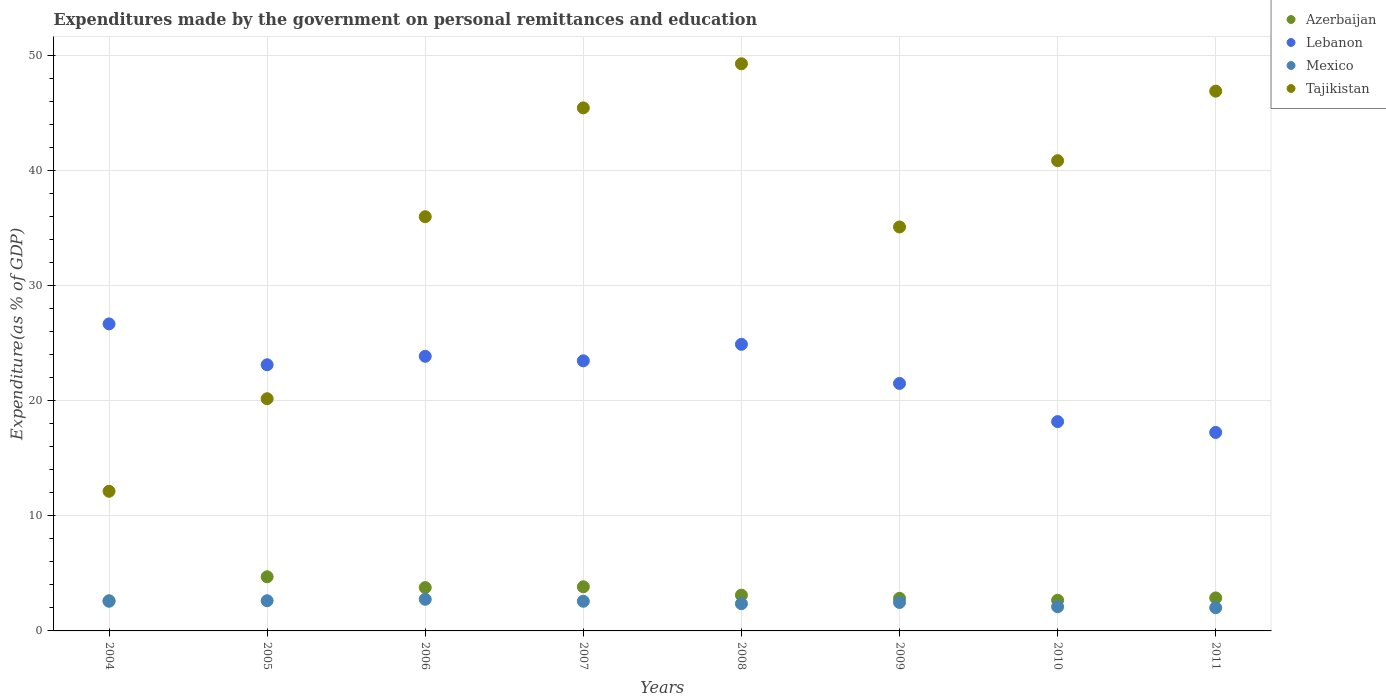How many different coloured dotlines are there?
Make the answer very short. 4. What is the expenditures made by the government on personal remittances and education in Lebanon in 2011?
Give a very brief answer. 17.25. Across all years, what is the maximum expenditures made by the government on personal remittances and education in Lebanon?
Your answer should be very brief. 26.68. Across all years, what is the minimum expenditures made by the government on personal remittances and education in Mexico?
Offer a terse response. 2.02. What is the total expenditures made by the government on personal remittances and education in Lebanon in the graph?
Keep it short and to the point. 179.01. What is the difference between the expenditures made by the government on personal remittances and education in Tajikistan in 2005 and that in 2009?
Make the answer very short. -14.93. What is the difference between the expenditures made by the government on personal remittances and education in Tajikistan in 2007 and the expenditures made by the government on personal remittances and education in Azerbaijan in 2008?
Provide a short and direct response. 42.35. What is the average expenditures made by the government on personal remittances and education in Lebanon per year?
Make the answer very short. 22.38. In the year 2005, what is the difference between the expenditures made by the government on personal remittances and education in Tajikistan and expenditures made by the government on personal remittances and education in Lebanon?
Your answer should be very brief. -2.95. What is the ratio of the expenditures made by the government on personal remittances and education in Azerbaijan in 2008 to that in 2010?
Your response must be concise. 1.17. What is the difference between the highest and the second highest expenditures made by the government on personal remittances and education in Azerbaijan?
Offer a terse response. 0.87. What is the difference between the highest and the lowest expenditures made by the government on personal remittances and education in Tajikistan?
Your answer should be compact. 37.15. In how many years, is the expenditures made by the government on personal remittances and education in Lebanon greater than the average expenditures made by the government on personal remittances and education in Lebanon taken over all years?
Offer a very short reply. 5. Is the sum of the expenditures made by the government on personal remittances and education in Tajikistan in 2008 and 2011 greater than the maximum expenditures made by the government on personal remittances and education in Mexico across all years?
Offer a terse response. Yes. Is it the case that in every year, the sum of the expenditures made by the government on personal remittances and education in Lebanon and expenditures made by the government on personal remittances and education in Azerbaijan  is greater than the sum of expenditures made by the government on personal remittances and education in Tajikistan and expenditures made by the government on personal remittances and education in Mexico?
Give a very brief answer. No. Does the expenditures made by the government on personal remittances and education in Lebanon monotonically increase over the years?
Ensure brevity in your answer.  No. How many years are there in the graph?
Keep it short and to the point. 8. Does the graph contain any zero values?
Offer a terse response. No. How are the legend labels stacked?
Give a very brief answer. Vertical. What is the title of the graph?
Your answer should be compact. Expenditures made by the government on personal remittances and education. Does "Liberia" appear as one of the legend labels in the graph?
Your answer should be very brief. No. What is the label or title of the X-axis?
Provide a short and direct response. Years. What is the label or title of the Y-axis?
Your response must be concise. Expenditure(as % of GDP). What is the Expenditure(as % of GDP) in Azerbaijan in 2004?
Offer a very short reply. 2.62. What is the Expenditure(as % of GDP) of Lebanon in 2004?
Provide a succinct answer. 26.68. What is the Expenditure(as % of GDP) of Mexico in 2004?
Offer a terse response. 2.58. What is the Expenditure(as % of GDP) of Tajikistan in 2004?
Your answer should be very brief. 12.14. What is the Expenditure(as % of GDP) of Azerbaijan in 2005?
Give a very brief answer. 4.71. What is the Expenditure(as % of GDP) in Lebanon in 2005?
Give a very brief answer. 23.13. What is the Expenditure(as % of GDP) of Mexico in 2005?
Ensure brevity in your answer.  2.63. What is the Expenditure(as % of GDP) in Tajikistan in 2005?
Make the answer very short. 20.18. What is the Expenditure(as % of GDP) in Azerbaijan in 2006?
Offer a very short reply. 3.77. What is the Expenditure(as % of GDP) of Lebanon in 2006?
Provide a succinct answer. 23.87. What is the Expenditure(as % of GDP) of Mexico in 2006?
Your answer should be compact. 2.75. What is the Expenditure(as % of GDP) in Tajikistan in 2006?
Offer a terse response. 36. What is the Expenditure(as % of GDP) of Azerbaijan in 2007?
Your answer should be very brief. 3.84. What is the Expenditure(as % of GDP) in Lebanon in 2007?
Ensure brevity in your answer.  23.47. What is the Expenditure(as % of GDP) of Mexico in 2007?
Make the answer very short. 2.58. What is the Expenditure(as % of GDP) of Tajikistan in 2007?
Offer a very short reply. 45.46. What is the Expenditure(as % of GDP) in Azerbaijan in 2008?
Provide a succinct answer. 3.11. What is the Expenditure(as % of GDP) of Lebanon in 2008?
Your answer should be very brief. 24.91. What is the Expenditure(as % of GDP) of Mexico in 2008?
Offer a terse response. 2.36. What is the Expenditure(as % of GDP) of Tajikistan in 2008?
Your answer should be very brief. 49.29. What is the Expenditure(as % of GDP) of Azerbaijan in 2009?
Offer a terse response. 2.83. What is the Expenditure(as % of GDP) of Lebanon in 2009?
Your response must be concise. 21.51. What is the Expenditure(as % of GDP) in Mexico in 2009?
Offer a very short reply. 2.47. What is the Expenditure(as % of GDP) in Tajikistan in 2009?
Your response must be concise. 35.11. What is the Expenditure(as % of GDP) in Azerbaijan in 2010?
Provide a succinct answer. 2.67. What is the Expenditure(as % of GDP) of Lebanon in 2010?
Offer a terse response. 18.19. What is the Expenditure(as % of GDP) in Mexico in 2010?
Make the answer very short. 2.1. What is the Expenditure(as % of GDP) of Tajikistan in 2010?
Your response must be concise. 40.87. What is the Expenditure(as % of GDP) in Azerbaijan in 2011?
Provide a succinct answer. 2.87. What is the Expenditure(as % of GDP) in Lebanon in 2011?
Ensure brevity in your answer.  17.25. What is the Expenditure(as % of GDP) of Mexico in 2011?
Keep it short and to the point. 2.02. What is the Expenditure(as % of GDP) in Tajikistan in 2011?
Give a very brief answer. 46.91. Across all years, what is the maximum Expenditure(as % of GDP) of Azerbaijan?
Make the answer very short. 4.71. Across all years, what is the maximum Expenditure(as % of GDP) of Lebanon?
Provide a short and direct response. 26.68. Across all years, what is the maximum Expenditure(as % of GDP) in Mexico?
Your answer should be very brief. 2.75. Across all years, what is the maximum Expenditure(as % of GDP) of Tajikistan?
Your response must be concise. 49.29. Across all years, what is the minimum Expenditure(as % of GDP) of Azerbaijan?
Offer a terse response. 2.62. Across all years, what is the minimum Expenditure(as % of GDP) of Lebanon?
Your answer should be compact. 17.25. Across all years, what is the minimum Expenditure(as % of GDP) in Mexico?
Provide a short and direct response. 2.02. Across all years, what is the minimum Expenditure(as % of GDP) in Tajikistan?
Make the answer very short. 12.14. What is the total Expenditure(as % of GDP) in Azerbaijan in the graph?
Ensure brevity in your answer.  26.41. What is the total Expenditure(as % of GDP) of Lebanon in the graph?
Your answer should be very brief. 179.01. What is the total Expenditure(as % of GDP) in Mexico in the graph?
Ensure brevity in your answer.  19.49. What is the total Expenditure(as % of GDP) of Tajikistan in the graph?
Ensure brevity in your answer.  285.95. What is the difference between the Expenditure(as % of GDP) in Azerbaijan in 2004 and that in 2005?
Give a very brief answer. -2.08. What is the difference between the Expenditure(as % of GDP) of Lebanon in 2004 and that in 2005?
Offer a very short reply. 3.55. What is the difference between the Expenditure(as % of GDP) in Mexico in 2004 and that in 2005?
Offer a very short reply. -0.05. What is the difference between the Expenditure(as % of GDP) of Tajikistan in 2004 and that in 2005?
Keep it short and to the point. -8.04. What is the difference between the Expenditure(as % of GDP) of Azerbaijan in 2004 and that in 2006?
Provide a succinct answer. -1.14. What is the difference between the Expenditure(as % of GDP) of Lebanon in 2004 and that in 2006?
Keep it short and to the point. 2.82. What is the difference between the Expenditure(as % of GDP) of Mexico in 2004 and that in 2006?
Provide a short and direct response. -0.17. What is the difference between the Expenditure(as % of GDP) of Tajikistan in 2004 and that in 2006?
Give a very brief answer. -23.86. What is the difference between the Expenditure(as % of GDP) in Azerbaijan in 2004 and that in 2007?
Make the answer very short. -1.21. What is the difference between the Expenditure(as % of GDP) in Lebanon in 2004 and that in 2007?
Provide a succinct answer. 3.21. What is the difference between the Expenditure(as % of GDP) in Mexico in 2004 and that in 2007?
Keep it short and to the point. 0. What is the difference between the Expenditure(as % of GDP) of Tajikistan in 2004 and that in 2007?
Offer a terse response. -33.32. What is the difference between the Expenditure(as % of GDP) of Azerbaijan in 2004 and that in 2008?
Your answer should be very brief. -0.49. What is the difference between the Expenditure(as % of GDP) in Lebanon in 2004 and that in 2008?
Offer a very short reply. 1.78. What is the difference between the Expenditure(as % of GDP) in Mexico in 2004 and that in 2008?
Your answer should be compact. 0.21. What is the difference between the Expenditure(as % of GDP) of Tajikistan in 2004 and that in 2008?
Ensure brevity in your answer.  -37.15. What is the difference between the Expenditure(as % of GDP) in Azerbaijan in 2004 and that in 2009?
Give a very brief answer. -0.21. What is the difference between the Expenditure(as % of GDP) of Lebanon in 2004 and that in 2009?
Make the answer very short. 5.17. What is the difference between the Expenditure(as % of GDP) of Mexico in 2004 and that in 2009?
Make the answer very short. 0.11. What is the difference between the Expenditure(as % of GDP) in Tajikistan in 2004 and that in 2009?
Offer a terse response. -22.97. What is the difference between the Expenditure(as % of GDP) in Azerbaijan in 2004 and that in 2010?
Keep it short and to the point. -0.04. What is the difference between the Expenditure(as % of GDP) in Lebanon in 2004 and that in 2010?
Provide a succinct answer. 8.49. What is the difference between the Expenditure(as % of GDP) in Mexico in 2004 and that in 2010?
Give a very brief answer. 0.48. What is the difference between the Expenditure(as % of GDP) in Tajikistan in 2004 and that in 2010?
Offer a terse response. -28.73. What is the difference between the Expenditure(as % of GDP) of Azerbaijan in 2004 and that in 2011?
Keep it short and to the point. -0.25. What is the difference between the Expenditure(as % of GDP) of Lebanon in 2004 and that in 2011?
Offer a terse response. 9.43. What is the difference between the Expenditure(as % of GDP) in Mexico in 2004 and that in 2011?
Provide a succinct answer. 0.56. What is the difference between the Expenditure(as % of GDP) of Tajikistan in 2004 and that in 2011?
Keep it short and to the point. -34.77. What is the difference between the Expenditure(as % of GDP) of Azerbaijan in 2005 and that in 2006?
Provide a succinct answer. 0.94. What is the difference between the Expenditure(as % of GDP) in Lebanon in 2005 and that in 2006?
Give a very brief answer. -0.74. What is the difference between the Expenditure(as % of GDP) of Mexico in 2005 and that in 2006?
Offer a terse response. -0.12. What is the difference between the Expenditure(as % of GDP) of Tajikistan in 2005 and that in 2006?
Give a very brief answer. -15.82. What is the difference between the Expenditure(as % of GDP) of Azerbaijan in 2005 and that in 2007?
Your answer should be very brief. 0.87. What is the difference between the Expenditure(as % of GDP) of Lebanon in 2005 and that in 2007?
Offer a very short reply. -0.34. What is the difference between the Expenditure(as % of GDP) of Mexico in 2005 and that in 2007?
Your answer should be compact. 0.05. What is the difference between the Expenditure(as % of GDP) of Tajikistan in 2005 and that in 2007?
Keep it short and to the point. -25.28. What is the difference between the Expenditure(as % of GDP) of Azerbaijan in 2005 and that in 2008?
Ensure brevity in your answer.  1.6. What is the difference between the Expenditure(as % of GDP) of Lebanon in 2005 and that in 2008?
Provide a short and direct response. -1.77. What is the difference between the Expenditure(as % of GDP) of Mexico in 2005 and that in 2008?
Provide a succinct answer. 0.26. What is the difference between the Expenditure(as % of GDP) in Tajikistan in 2005 and that in 2008?
Your response must be concise. -29.11. What is the difference between the Expenditure(as % of GDP) of Azerbaijan in 2005 and that in 2009?
Provide a succinct answer. 1.87. What is the difference between the Expenditure(as % of GDP) in Lebanon in 2005 and that in 2009?
Offer a very short reply. 1.62. What is the difference between the Expenditure(as % of GDP) in Mexico in 2005 and that in 2009?
Provide a succinct answer. 0.15. What is the difference between the Expenditure(as % of GDP) of Tajikistan in 2005 and that in 2009?
Give a very brief answer. -14.93. What is the difference between the Expenditure(as % of GDP) of Azerbaijan in 2005 and that in 2010?
Your answer should be very brief. 2.04. What is the difference between the Expenditure(as % of GDP) of Lebanon in 2005 and that in 2010?
Offer a terse response. 4.94. What is the difference between the Expenditure(as % of GDP) of Mexico in 2005 and that in 2010?
Your answer should be very brief. 0.52. What is the difference between the Expenditure(as % of GDP) in Tajikistan in 2005 and that in 2010?
Provide a succinct answer. -20.69. What is the difference between the Expenditure(as % of GDP) of Azerbaijan in 2005 and that in 2011?
Your answer should be compact. 1.83. What is the difference between the Expenditure(as % of GDP) in Lebanon in 2005 and that in 2011?
Your answer should be compact. 5.88. What is the difference between the Expenditure(as % of GDP) in Mexico in 2005 and that in 2011?
Provide a short and direct response. 0.61. What is the difference between the Expenditure(as % of GDP) in Tajikistan in 2005 and that in 2011?
Your answer should be compact. -26.73. What is the difference between the Expenditure(as % of GDP) of Azerbaijan in 2006 and that in 2007?
Give a very brief answer. -0.07. What is the difference between the Expenditure(as % of GDP) of Lebanon in 2006 and that in 2007?
Give a very brief answer. 0.39. What is the difference between the Expenditure(as % of GDP) of Mexico in 2006 and that in 2007?
Provide a short and direct response. 0.17. What is the difference between the Expenditure(as % of GDP) of Tajikistan in 2006 and that in 2007?
Make the answer very short. -9.46. What is the difference between the Expenditure(as % of GDP) in Azerbaijan in 2006 and that in 2008?
Give a very brief answer. 0.66. What is the difference between the Expenditure(as % of GDP) of Lebanon in 2006 and that in 2008?
Provide a succinct answer. -1.04. What is the difference between the Expenditure(as % of GDP) of Mexico in 2006 and that in 2008?
Give a very brief answer. 0.39. What is the difference between the Expenditure(as % of GDP) of Tajikistan in 2006 and that in 2008?
Keep it short and to the point. -13.29. What is the difference between the Expenditure(as % of GDP) of Azerbaijan in 2006 and that in 2009?
Provide a short and direct response. 0.93. What is the difference between the Expenditure(as % of GDP) of Lebanon in 2006 and that in 2009?
Ensure brevity in your answer.  2.36. What is the difference between the Expenditure(as % of GDP) of Mexico in 2006 and that in 2009?
Your answer should be very brief. 0.28. What is the difference between the Expenditure(as % of GDP) of Tajikistan in 2006 and that in 2009?
Provide a succinct answer. 0.89. What is the difference between the Expenditure(as % of GDP) of Azerbaijan in 2006 and that in 2010?
Keep it short and to the point. 1.1. What is the difference between the Expenditure(as % of GDP) in Lebanon in 2006 and that in 2010?
Offer a terse response. 5.68. What is the difference between the Expenditure(as % of GDP) in Mexico in 2006 and that in 2010?
Your answer should be compact. 0.65. What is the difference between the Expenditure(as % of GDP) of Tajikistan in 2006 and that in 2010?
Provide a short and direct response. -4.87. What is the difference between the Expenditure(as % of GDP) in Azerbaijan in 2006 and that in 2011?
Give a very brief answer. 0.9. What is the difference between the Expenditure(as % of GDP) of Lebanon in 2006 and that in 2011?
Your response must be concise. 6.62. What is the difference between the Expenditure(as % of GDP) of Mexico in 2006 and that in 2011?
Your answer should be compact. 0.73. What is the difference between the Expenditure(as % of GDP) in Tajikistan in 2006 and that in 2011?
Your response must be concise. -10.91. What is the difference between the Expenditure(as % of GDP) of Azerbaijan in 2007 and that in 2008?
Make the answer very short. 0.73. What is the difference between the Expenditure(as % of GDP) of Lebanon in 2007 and that in 2008?
Offer a terse response. -1.43. What is the difference between the Expenditure(as % of GDP) in Mexico in 2007 and that in 2008?
Keep it short and to the point. 0.21. What is the difference between the Expenditure(as % of GDP) in Tajikistan in 2007 and that in 2008?
Your answer should be compact. -3.83. What is the difference between the Expenditure(as % of GDP) in Azerbaijan in 2007 and that in 2009?
Make the answer very short. 1. What is the difference between the Expenditure(as % of GDP) in Lebanon in 2007 and that in 2009?
Make the answer very short. 1.97. What is the difference between the Expenditure(as % of GDP) in Mexico in 2007 and that in 2009?
Your answer should be very brief. 0.11. What is the difference between the Expenditure(as % of GDP) in Tajikistan in 2007 and that in 2009?
Provide a short and direct response. 10.35. What is the difference between the Expenditure(as % of GDP) in Azerbaijan in 2007 and that in 2010?
Offer a very short reply. 1.17. What is the difference between the Expenditure(as % of GDP) in Lebanon in 2007 and that in 2010?
Ensure brevity in your answer.  5.28. What is the difference between the Expenditure(as % of GDP) in Mexico in 2007 and that in 2010?
Give a very brief answer. 0.47. What is the difference between the Expenditure(as % of GDP) in Tajikistan in 2007 and that in 2010?
Offer a very short reply. 4.59. What is the difference between the Expenditure(as % of GDP) of Azerbaijan in 2007 and that in 2011?
Give a very brief answer. 0.97. What is the difference between the Expenditure(as % of GDP) in Lebanon in 2007 and that in 2011?
Ensure brevity in your answer.  6.22. What is the difference between the Expenditure(as % of GDP) in Mexico in 2007 and that in 2011?
Offer a very short reply. 0.56. What is the difference between the Expenditure(as % of GDP) of Tajikistan in 2007 and that in 2011?
Ensure brevity in your answer.  -1.45. What is the difference between the Expenditure(as % of GDP) in Azerbaijan in 2008 and that in 2009?
Provide a succinct answer. 0.28. What is the difference between the Expenditure(as % of GDP) in Lebanon in 2008 and that in 2009?
Ensure brevity in your answer.  3.4. What is the difference between the Expenditure(as % of GDP) in Mexico in 2008 and that in 2009?
Your response must be concise. -0.11. What is the difference between the Expenditure(as % of GDP) of Tajikistan in 2008 and that in 2009?
Provide a short and direct response. 14.18. What is the difference between the Expenditure(as % of GDP) of Azerbaijan in 2008 and that in 2010?
Your answer should be very brief. 0.44. What is the difference between the Expenditure(as % of GDP) in Lebanon in 2008 and that in 2010?
Keep it short and to the point. 6.72. What is the difference between the Expenditure(as % of GDP) in Mexico in 2008 and that in 2010?
Your answer should be very brief. 0.26. What is the difference between the Expenditure(as % of GDP) in Tajikistan in 2008 and that in 2010?
Your response must be concise. 8.42. What is the difference between the Expenditure(as % of GDP) in Azerbaijan in 2008 and that in 2011?
Your response must be concise. 0.24. What is the difference between the Expenditure(as % of GDP) of Lebanon in 2008 and that in 2011?
Offer a terse response. 7.66. What is the difference between the Expenditure(as % of GDP) in Mexico in 2008 and that in 2011?
Your answer should be compact. 0.35. What is the difference between the Expenditure(as % of GDP) in Tajikistan in 2008 and that in 2011?
Provide a succinct answer. 2.38. What is the difference between the Expenditure(as % of GDP) of Azerbaijan in 2009 and that in 2010?
Provide a succinct answer. 0.17. What is the difference between the Expenditure(as % of GDP) of Lebanon in 2009 and that in 2010?
Give a very brief answer. 3.32. What is the difference between the Expenditure(as % of GDP) in Mexico in 2009 and that in 2010?
Offer a terse response. 0.37. What is the difference between the Expenditure(as % of GDP) in Tajikistan in 2009 and that in 2010?
Keep it short and to the point. -5.76. What is the difference between the Expenditure(as % of GDP) in Azerbaijan in 2009 and that in 2011?
Ensure brevity in your answer.  -0.04. What is the difference between the Expenditure(as % of GDP) of Lebanon in 2009 and that in 2011?
Offer a terse response. 4.26. What is the difference between the Expenditure(as % of GDP) of Mexico in 2009 and that in 2011?
Offer a very short reply. 0.45. What is the difference between the Expenditure(as % of GDP) in Tajikistan in 2009 and that in 2011?
Your answer should be very brief. -11.8. What is the difference between the Expenditure(as % of GDP) in Azerbaijan in 2010 and that in 2011?
Offer a very short reply. -0.2. What is the difference between the Expenditure(as % of GDP) of Lebanon in 2010 and that in 2011?
Ensure brevity in your answer.  0.94. What is the difference between the Expenditure(as % of GDP) of Mexico in 2010 and that in 2011?
Provide a succinct answer. 0.09. What is the difference between the Expenditure(as % of GDP) in Tajikistan in 2010 and that in 2011?
Offer a very short reply. -6.04. What is the difference between the Expenditure(as % of GDP) in Azerbaijan in 2004 and the Expenditure(as % of GDP) in Lebanon in 2005?
Provide a succinct answer. -20.51. What is the difference between the Expenditure(as % of GDP) of Azerbaijan in 2004 and the Expenditure(as % of GDP) of Mexico in 2005?
Your response must be concise. -0. What is the difference between the Expenditure(as % of GDP) in Azerbaijan in 2004 and the Expenditure(as % of GDP) in Tajikistan in 2005?
Give a very brief answer. -17.56. What is the difference between the Expenditure(as % of GDP) of Lebanon in 2004 and the Expenditure(as % of GDP) of Mexico in 2005?
Offer a terse response. 24.06. What is the difference between the Expenditure(as % of GDP) of Lebanon in 2004 and the Expenditure(as % of GDP) of Tajikistan in 2005?
Ensure brevity in your answer.  6.5. What is the difference between the Expenditure(as % of GDP) in Mexico in 2004 and the Expenditure(as % of GDP) in Tajikistan in 2005?
Provide a succinct answer. -17.6. What is the difference between the Expenditure(as % of GDP) in Azerbaijan in 2004 and the Expenditure(as % of GDP) in Lebanon in 2006?
Your response must be concise. -21.25. What is the difference between the Expenditure(as % of GDP) in Azerbaijan in 2004 and the Expenditure(as % of GDP) in Mexico in 2006?
Your response must be concise. -0.13. What is the difference between the Expenditure(as % of GDP) of Azerbaijan in 2004 and the Expenditure(as % of GDP) of Tajikistan in 2006?
Offer a very short reply. -33.38. What is the difference between the Expenditure(as % of GDP) in Lebanon in 2004 and the Expenditure(as % of GDP) in Mexico in 2006?
Give a very brief answer. 23.93. What is the difference between the Expenditure(as % of GDP) of Lebanon in 2004 and the Expenditure(as % of GDP) of Tajikistan in 2006?
Your answer should be compact. -9.32. What is the difference between the Expenditure(as % of GDP) of Mexico in 2004 and the Expenditure(as % of GDP) of Tajikistan in 2006?
Provide a short and direct response. -33.42. What is the difference between the Expenditure(as % of GDP) in Azerbaijan in 2004 and the Expenditure(as % of GDP) in Lebanon in 2007?
Your answer should be compact. -20.85. What is the difference between the Expenditure(as % of GDP) of Azerbaijan in 2004 and the Expenditure(as % of GDP) of Mexico in 2007?
Your response must be concise. 0.04. What is the difference between the Expenditure(as % of GDP) of Azerbaijan in 2004 and the Expenditure(as % of GDP) of Tajikistan in 2007?
Ensure brevity in your answer.  -42.83. What is the difference between the Expenditure(as % of GDP) of Lebanon in 2004 and the Expenditure(as % of GDP) of Mexico in 2007?
Offer a terse response. 24.11. What is the difference between the Expenditure(as % of GDP) in Lebanon in 2004 and the Expenditure(as % of GDP) in Tajikistan in 2007?
Give a very brief answer. -18.77. What is the difference between the Expenditure(as % of GDP) in Mexico in 2004 and the Expenditure(as % of GDP) in Tajikistan in 2007?
Your answer should be compact. -42.88. What is the difference between the Expenditure(as % of GDP) in Azerbaijan in 2004 and the Expenditure(as % of GDP) in Lebanon in 2008?
Keep it short and to the point. -22.29. What is the difference between the Expenditure(as % of GDP) in Azerbaijan in 2004 and the Expenditure(as % of GDP) in Mexico in 2008?
Offer a terse response. 0.26. What is the difference between the Expenditure(as % of GDP) of Azerbaijan in 2004 and the Expenditure(as % of GDP) of Tajikistan in 2008?
Your answer should be compact. -46.67. What is the difference between the Expenditure(as % of GDP) of Lebanon in 2004 and the Expenditure(as % of GDP) of Mexico in 2008?
Offer a terse response. 24.32. What is the difference between the Expenditure(as % of GDP) of Lebanon in 2004 and the Expenditure(as % of GDP) of Tajikistan in 2008?
Your answer should be compact. -22.61. What is the difference between the Expenditure(as % of GDP) in Mexico in 2004 and the Expenditure(as % of GDP) in Tajikistan in 2008?
Offer a very short reply. -46.71. What is the difference between the Expenditure(as % of GDP) in Azerbaijan in 2004 and the Expenditure(as % of GDP) in Lebanon in 2009?
Provide a short and direct response. -18.89. What is the difference between the Expenditure(as % of GDP) in Azerbaijan in 2004 and the Expenditure(as % of GDP) in Mexico in 2009?
Your answer should be very brief. 0.15. What is the difference between the Expenditure(as % of GDP) in Azerbaijan in 2004 and the Expenditure(as % of GDP) in Tajikistan in 2009?
Your answer should be very brief. -32.49. What is the difference between the Expenditure(as % of GDP) of Lebanon in 2004 and the Expenditure(as % of GDP) of Mexico in 2009?
Make the answer very short. 24.21. What is the difference between the Expenditure(as % of GDP) in Lebanon in 2004 and the Expenditure(as % of GDP) in Tajikistan in 2009?
Give a very brief answer. -8.42. What is the difference between the Expenditure(as % of GDP) of Mexico in 2004 and the Expenditure(as % of GDP) of Tajikistan in 2009?
Your response must be concise. -32.53. What is the difference between the Expenditure(as % of GDP) in Azerbaijan in 2004 and the Expenditure(as % of GDP) in Lebanon in 2010?
Offer a terse response. -15.57. What is the difference between the Expenditure(as % of GDP) in Azerbaijan in 2004 and the Expenditure(as % of GDP) in Mexico in 2010?
Offer a very short reply. 0.52. What is the difference between the Expenditure(as % of GDP) of Azerbaijan in 2004 and the Expenditure(as % of GDP) of Tajikistan in 2010?
Offer a terse response. -38.25. What is the difference between the Expenditure(as % of GDP) in Lebanon in 2004 and the Expenditure(as % of GDP) in Mexico in 2010?
Offer a very short reply. 24.58. What is the difference between the Expenditure(as % of GDP) in Lebanon in 2004 and the Expenditure(as % of GDP) in Tajikistan in 2010?
Keep it short and to the point. -14.18. What is the difference between the Expenditure(as % of GDP) in Mexico in 2004 and the Expenditure(as % of GDP) in Tajikistan in 2010?
Your answer should be compact. -38.29. What is the difference between the Expenditure(as % of GDP) in Azerbaijan in 2004 and the Expenditure(as % of GDP) in Lebanon in 2011?
Offer a very short reply. -14.63. What is the difference between the Expenditure(as % of GDP) of Azerbaijan in 2004 and the Expenditure(as % of GDP) of Mexico in 2011?
Keep it short and to the point. 0.6. What is the difference between the Expenditure(as % of GDP) of Azerbaijan in 2004 and the Expenditure(as % of GDP) of Tajikistan in 2011?
Your response must be concise. -44.29. What is the difference between the Expenditure(as % of GDP) of Lebanon in 2004 and the Expenditure(as % of GDP) of Mexico in 2011?
Ensure brevity in your answer.  24.67. What is the difference between the Expenditure(as % of GDP) of Lebanon in 2004 and the Expenditure(as % of GDP) of Tajikistan in 2011?
Give a very brief answer. -20.23. What is the difference between the Expenditure(as % of GDP) in Mexico in 2004 and the Expenditure(as % of GDP) in Tajikistan in 2011?
Make the answer very short. -44.33. What is the difference between the Expenditure(as % of GDP) in Azerbaijan in 2005 and the Expenditure(as % of GDP) in Lebanon in 2006?
Offer a very short reply. -19.16. What is the difference between the Expenditure(as % of GDP) in Azerbaijan in 2005 and the Expenditure(as % of GDP) in Mexico in 2006?
Your answer should be compact. 1.96. What is the difference between the Expenditure(as % of GDP) of Azerbaijan in 2005 and the Expenditure(as % of GDP) of Tajikistan in 2006?
Give a very brief answer. -31.29. What is the difference between the Expenditure(as % of GDP) in Lebanon in 2005 and the Expenditure(as % of GDP) in Mexico in 2006?
Your answer should be very brief. 20.38. What is the difference between the Expenditure(as % of GDP) in Lebanon in 2005 and the Expenditure(as % of GDP) in Tajikistan in 2006?
Provide a succinct answer. -12.87. What is the difference between the Expenditure(as % of GDP) in Mexico in 2005 and the Expenditure(as % of GDP) in Tajikistan in 2006?
Keep it short and to the point. -33.37. What is the difference between the Expenditure(as % of GDP) of Azerbaijan in 2005 and the Expenditure(as % of GDP) of Lebanon in 2007?
Keep it short and to the point. -18.77. What is the difference between the Expenditure(as % of GDP) in Azerbaijan in 2005 and the Expenditure(as % of GDP) in Mexico in 2007?
Give a very brief answer. 2.13. What is the difference between the Expenditure(as % of GDP) of Azerbaijan in 2005 and the Expenditure(as % of GDP) of Tajikistan in 2007?
Offer a terse response. -40.75. What is the difference between the Expenditure(as % of GDP) in Lebanon in 2005 and the Expenditure(as % of GDP) in Mexico in 2007?
Offer a terse response. 20.56. What is the difference between the Expenditure(as % of GDP) in Lebanon in 2005 and the Expenditure(as % of GDP) in Tajikistan in 2007?
Provide a short and direct response. -22.32. What is the difference between the Expenditure(as % of GDP) of Mexico in 2005 and the Expenditure(as % of GDP) of Tajikistan in 2007?
Give a very brief answer. -42.83. What is the difference between the Expenditure(as % of GDP) of Azerbaijan in 2005 and the Expenditure(as % of GDP) of Lebanon in 2008?
Your response must be concise. -20.2. What is the difference between the Expenditure(as % of GDP) of Azerbaijan in 2005 and the Expenditure(as % of GDP) of Mexico in 2008?
Offer a very short reply. 2.34. What is the difference between the Expenditure(as % of GDP) of Azerbaijan in 2005 and the Expenditure(as % of GDP) of Tajikistan in 2008?
Provide a succinct answer. -44.59. What is the difference between the Expenditure(as % of GDP) of Lebanon in 2005 and the Expenditure(as % of GDP) of Mexico in 2008?
Offer a terse response. 20.77. What is the difference between the Expenditure(as % of GDP) of Lebanon in 2005 and the Expenditure(as % of GDP) of Tajikistan in 2008?
Give a very brief answer. -26.16. What is the difference between the Expenditure(as % of GDP) in Mexico in 2005 and the Expenditure(as % of GDP) in Tajikistan in 2008?
Offer a terse response. -46.67. What is the difference between the Expenditure(as % of GDP) of Azerbaijan in 2005 and the Expenditure(as % of GDP) of Lebanon in 2009?
Provide a succinct answer. -16.8. What is the difference between the Expenditure(as % of GDP) in Azerbaijan in 2005 and the Expenditure(as % of GDP) in Mexico in 2009?
Provide a succinct answer. 2.23. What is the difference between the Expenditure(as % of GDP) of Azerbaijan in 2005 and the Expenditure(as % of GDP) of Tajikistan in 2009?
Your answer should be compact. -30.4. What is the difference between the Expenditure(as % of GDP) of Lebanon in 2005 and the Expenditure(as % of GDP) of Mexico in 2009?
Keep it short and to the point. 20.66. What is the difference between the Expenditure(as % of GDP) in Lebanon in 2005 and the Expenditure(as % of GDP) in Tajikistan in 2009?
Your response must be concise. -11.97. What is the difference between the Expenditure(as % of GDP) in Mexico in 2005 and the Expenditure(as % of GDP) in Tajikistan in 2009?
Ensure brevity in your answer.  -32.48. What is the difference between the Expenditure(as % of GDP) in Azerbaijan in 2005 and the Expenditure(as % of GDP) in Lebanon in 2010?
Keep it short and to the point. -13.48. What is the difference between the Expenditure(as % of GDP) of Azerbaijan in 2005 and the Expenditure(as % of GDP) of Mexico in 2010?
Offer a terse response. 2.6. What is the difference between the Expenditure(as % of GDP) of Azerbaijan in 2005 and the Expenditure(as % of GDP) of Tajikistan in 2010?
Provide a short and direct response. -36.16. What is the difference between the Expenditure(as % of GDP) in Lebanon in 2005 and the Expenditure(as % of GDP) in Mexico in 2010?
Provide a short and direct response. 21.03. What is the difference between the Expenditure(as % of GDP) of Lebanon in 2005 and the Expenditure(as % of GDP) of Tajikistan in 2010?
Your answer should be compact. -17.73. What is the difference between the Expenditure(as % of GDP) of Mexico in 2005 and the Expenditure(as % of GDP) of Tajikistan in 2010?
Offer a very short reply. -38.24. What is the difference between the Expenditure(as % of GDP) of Azerbaijan in 2005 and the Expenditure(as % of GDP) of Lebanon in 2011?
Offer a very short reply. -12.54. What is the difference between the Expenditure(as % of GDP) in Azerbaijan in 2005 and the Expenditure(as % of GDP) in Mexico in 2011?
Your answer should be very brief. 2.69. What is the difference between the Expenditure(as % of GDP) of Azerbaijan in 2005 and the Expenditure(as % of GDP) of Tajikistan in 2011?
Offer a very short reply. -42.21. What is the difference between the Expenditure(as % of GDP) of Lebanon in 2005 and the Expenditure(as % of GDP) of Mexico in 2011?
Keep it short and to the point. 21.12. What is the difference between the Expenditure(as % of GDP) in Lebanon in 2005 and the Expenditure(as % of GDP) in Tajikistan in 2011?
Offer a very short reply. -23.78. What is the difference between the Expenditure(as % of GDP) of Mexico in 2005 and the Expenditure(as % of GDP) of Tajikistan in 2011?
Your response must be concise. -44.29. What is the difference between the Expenditure(as % of GDP) in Azerbaijan in 2006 and the Expenditure(as % of GDP) in Lebanon in 2007?
Your response must be concise. -19.71. What is the difference between the Expenditure(as % of GDP) of Azerbaijan in 2006 and the Expenditure(as % of GDP) of Mexico in 2007?
Make the answer very short. 1.19. What is the difference between the Expenditure(as % of GDP) of Azerbaijan in 2006 and the Expenditure(as % of GDP) of Tajikistan in 2007?
Give a very brief answer. -41.69. What is the difference between the Expenditure(as % of GDP) in Lebanon in 2006 and the Expenditure(as % of GDP) in Mexico in 2007?
Offer a terse response. 21.29. What is the difference between the Expenditure(as % of GDP) of Lebanon in 2006 and the Expenditure(as % of GDP) of Tajikistan in 2007?
Your response must be concise. -21.59. What is the difference between the Expenditure(as % of GDP) of Mexico in 2006 and the Expenditure(as % of GDP) of Tajikistan in 2007?
Your answer should be compact. -42.71. What is the difference between the Expenditure(as % of GDP) of Azerbaijan in 2006 and the Expenditure(as % of GDP) of Lebanon in 2008?
Your response must be concise. -21.14. What is the difference between the Expenditure(as % of GDP) in Azerbaijan in 2006 and the Expenditure(as % of GDP) in Mexico in 2008?
Your response must be concise. 1.4. What is the difference between the Expenditure(as % of GDP) of Azerbaijan in 2006 and the Expenditure(as % of GDP) of Tajikistan in 2008?
Your answer should be very brief. -45.52. What is the difference between the Expenditure(as % of GDP) in Lebanon in 2006 and the Expenditure(as % of GDP) in Mexico in 2008?
Make the answer very short. 21.5. What is the difference between the Expenditure(as % of GDP) of Lebanon in 2006 and the Expenditure(as % of GDP) of Tajikistan in 2008?
Provide a succinct answer. -25.42. What is the difference between the Expenditure(as % of GDP) in Mexico in 2006 and the Expenditure(as % of GDP) in Tajikistan in 2008?
Ensure brevity in your answer.  -46.54. What is the difference between the Expenditure(as % of GDP) of Azerbaijan in 2006 and the Expenditure(as % of GDP) of Lebanon in 2009?
Give a very brief answer. -17.74. What is the difference between the Expenditure(as % of GDP) of Azerbaijan in 2006 and the Expenditure(as % of GDP) of Mexico in 2009?
Your response must be concise. 1.29. What is the difference between the Expenditure(as % of GDP) of Azerbaijan in 2006 and the Expenditure(as % of GDP) of Tajikistan in 2009?
Provide a short and direct response. -31.34. What is the difference between the Expenditure(as % of GDP) of Lebanon in 2006 and the Expenditure(as % of GDP) of Mexico in 2009?
Ensure brevity in your answer.  21.4. What is the difference between the Expenditure(as % of GDP) in Lebanon in 2006 and the Expenditure(as % of GDP) in Tajikistan in 2009?
Ensure brevity in your answer.  -11.24. What is the difference between the Expenditure(as % of GDP) of Mexico in 2006 and the Expenditure(as % of GDP) of Tajikistan in 2009?
Your response must be concise. -32.36. What is the difference between the Expenditure(as % of GDP) of Azerbaijan in 2006 and the Expenditure(as % of GDP) of Lebanon in 2010?
Keep it short and to the point. -14.42. What is the difference between the Expenditure(as % of GDP) of Azerbaijan in 2006 and the Expenditure(as % of GDP) of Mexico in 2010?
Offer a very short reply. 1.66. What is the difference between the Expenditure(as % of GDP) of Azerbaijan in 2006 and the Expenditure(as % of GDP) of Tajikistan in 2010?
Keep it short and to the point. -37.1. What is the difference between the Expenditure(as % of GDP) of Lebanon in 2006 and the Expenditure(as % of GDP) of Mexico in 2010?
Provide a short and direct response. 21.76. What is the difference between the Expenditure(as % of GDP) in Lebanon in 2006 and the Expenditure(as % of GDP) in Tajikistan in 2010?
Offer a very short reply. -17. What is the difference between the Expenditure(as % of GDP) in Mexico in 2006 and the Expenditure(as % of GDP) in Tajikistan in 2010?
Your answer should be very brief. -38.12. What is the difference between the Expenditure(as % of GDP) of Azerbaijan in 2006 and the Expenditure(as % of GDP) of Lebanon in 2011?
Provide a succinct answer. -13.48. What is the difference between the Expenditure(as % of GDP) in Azerbaijan in 2006 and the Expenditure(as % of GDP) in Mexico in 2011?
Provide a short and direct response. 1.75. What is the difference between the Expenditure(as % of GDP) in Azerbaijan in 2006 and the Expenditure(as % of GDP) in Tajikistan in 2011?
Give a very brief answer. -43.14. What is the difference between the Expenditure(as % of GDP) of Lebanon in 2006 and the Expenditure(as % of GDP) of Mexico in 2011?
Provide a short and direct response. 21.85. What is the difference between the Expenditure(as % of GDP) of Lebanon in 2006 and the Expenditure(as % of GDP) of Tajikistan in 2011?
Your response must be concise. -23.04. What is the difference between the Expenditure(as % of GDP) of Mexico in 2006 and the Expenditure(as % of GDP) of Tajikistan in 2011?
Provide a succinct answer. -44.16. What is the difference between the Expenditure(as % of GDP) of Azerbaijan in 2007 and the Expenditure(as % of GDP) of Lebanon in 2008?
Give a very brief answer. -21.07. What is the difference between the Expenditure(as % of GDP) in Azerbaijan in 2007 and the Expenditure(as % of GDP) in Mexico in 2008?
Make the answer very short. 1.47. What is the difference between the Expenditure(as % of GDP) of Azerbaijan in 2007 and the Expenditure(as % of GDP) of Tajikistan in 2008?
Your answer should be compact. -45.45. What is the difference between the Expenditure(as % of GDP) of Lebanon in 2007 and the Expenditure(as % of GDP) of Mexico in 2008?
Provide a succinct answer. 21.11. What is the difference between the Expenditure(as % of GDP) in Lebanon in 2007 and the Expenditure(as % of GDP) in Tajikistan in 2008?
Provide a succinct answer. -25.82. What is the difference between the Expenditure(as % of GDP) in Mexico in 2007 and the Expenditure(as % of GDP) in Tajikistan in 2008?
Offer a very short reply. -46.71. What is the difference between the Expenditure(as % of GDP) in Azerbaijan in 2007 and the Expenditure(as % of GDP) in Lebanon in 2009?
Make the answer very short. -17.67. What is the difference between the Expenditure(as % of GDP) in Azerbaijan in 2007 and the Expenditure(as % of GDP) in Mexico in 2009?
Offer a very short reply. 1.36. What is the difference between the Expenditure(as % of GDP) of Azerbaijan in 2007 and the Expenditure(as % of GDP) of Tajikistan in 2009?
Provide a short and direct response. -31.27. What is the difference between the Expenditure(as % of GDP) of Lebanon in 2007 and the Expenditure(as % of GDP) of Mexico in 2009?
Keep it short and to the point. 21. What is the difference between the Expenditure(as % of GDP) in Lebanon in 2007 and the Expenditure(as % of GDP) in Tajikistan in 2009?
Make the answer very short. -11.63. What is the difference between the Expenditure(as % of GDP) in Mexico in 2007 and the Expenditure(as % of GDP) in Tajikistan in 2009?
Your answer should be very brief. -32.53. What is the difference between the Expenditure(as % of GDP) in Azerbaijan in 2007 and the Expenditure(as % of GDP) in Lebanon in 2010?
Provide a short and direct response. -14.35. What is the difference between the Expenditure(as % of GDP) in Azerbaijan in 2007 and the Expenditure(as % of GDP) in Mexico in 2010?
Offer a very short reply. 1.73. What is the difference between the Expenditure(as % of GDP) of Azerbaijan in 2007 and the Expenditure(as % of GDP) of Tajikistan in 2010?
Offer a terse response. -37.03. What is the difference between the Expenditure(as % of GDP) of Lebanon in 2007 and the Expenditure(as % of GDP) of Mexico in 2010?
Provide a succinct answer. 21.37. What is the difference between the Expenditure(as % of GDP) of Lebanon in 2007 and the Expenditure(as % of GDP) of Tajikistan in 2010?
Your answer should be compact. -17.39. What is the difference between the Expenditure(as % of GDP) in Mexico in 2007 and the Expenditure(as % of GDP) in Tajikistan in 2010?
Your answer should be compact. -38.29. What is the difference between the Expenditure(as % of GDP) of Azerbaijan in 2007 and the Expenditure(as % of GDP) of Lebanon in 2011?
Give a very brief answer. -13.41. What is the difference between the Expenditure(as % of GDP) in Azerbaijan in 2007 and the Expenditure(as % of GDP) in Mexico in 2011?
Offer a terse response. 1.82. What is the difference between the Expenditure(as % of GDP) of Azerbaijan in 2007 and the Expenditure(as % of GDP) of Tajikistan in 2011?
Provide a short and direct response. -43.08. What is the difference between the Expenditure(as % of GDP) of Lebanon in 2007 and the Expenditure(as % of GDP) of Mexico in 2011?
Ensure brevity in your answer.  21.46. What is the difference between the Expenditure(as % of GDP) in Lebanon in 2007 and the Expenditure(as % of GDP) in Tajikistan in 2011?
Provide a short and direct response. -23.44. What is the difference between the Expenditure(as % of GDP) of Mexico in 2007 and the Expenditure(as % of GDP) of Tajikistan in 2011?
Your answer should be compact. -44.33. What is the difference between the Expenditure(as % of GDP) in Azerbaijan in 2008 and the Expenditure(as % of GDP) in Lebanon in 2009?
Your answer should be compact. -18.4. What is the difference between the Expenditure(as % of GDP) of Azerbaijan in 2008 and the Expenditure(as % of GDP) of Mexico in 2009?
Your answer should be compact. 0.64. What is the difference between the Expenditure(as % of GDP) of Azerbaijan in 2008 and the Expenditure(as % of GDP) of Tajikistan in 2009?
Provide a short and direct response. -32. What is the difference between the Expenditure(as % of GDP) of Lebanon in 2008 and the Expenditure(as % of GDP) of Mexico in 2009?
Provide a succinct answer. 22.44. What is the difference between the Expenditure(as % of GDP) of Lebanon in 2008 and the Expenditure(as % of GDP) of Tajikistan in 2009?
Keep it short and to the point. -10.2. What is the difference between the Expenditure(as % of GDP) of Mexico in 2008 and the Expenditure(as % of GDP) of Tajikistan in 2009?
Provide a succinct answer. -32.74. What is the difference between the Expenditure(as % of GDP) of Azerbaijan in 2008 and the Expenditure(as % of GDP) of Lebanon in 2010?
Your answer should be compact. -15.08. What is the difference between the Expenditure(as % of GDP) in Azerbaijan in 2008 and the Expenditure(as % of GDP) in Mexico in 2010?
Ensure brevity in your answer.  1. What is the difference between the Expenditure(as % of GDP) in Azerbaijan in 2008 and the Expenditure(as % of GDP) in Tajikistan in 2010?
Keep it short and to the point. -37.76. What is the difference between the Expenditure(as % of GDP) of Lebanon in 2008 and the Expenditure(as % of GDP) of Mexico in 2010?
Offer a very short reply. 22.8. What is the difference between the Expenditure(as % of GDP) of Lebanon in 2008 and the Expenditure(as % of GDP) of Tajikistan in 2010?
Ensure brevity in your answer.  -15.96. What is the difference between the Expenditure(as % of GDP) in Mexico in 2008 and the Expenditure(as % of GDP) in Tajikistan in 2010?
Ensure brevity in your answer.  -38.5. What is the difference between the Expenditure(as % of GDP) in Azerbaijan in 2008 and the Expenditure(as % of GDP) in Lebanon in 2011?
Provide a succinct answer. -14.14. What is the difference between the Expenditure(as % of GDP) in Azerbaijan in 2008 and the Expenditure(as % of GDP) in Mexico in 2011?
Provide a succinct answer. 1.09. What is the difference between the Expenditure(as % of GDP) of Azerbaijan in 2008 and the Expenditure(as % of GDP) of Tajikistan in 2011?
Provide a succinct answer. -43.8. What is the difference between the Expenditure(as % of GDP) of Lebanon in 2008 and the Expenditure(as % of GDP) of Mexico in 2011?
Provide a short and direct response. 22.89. What is the difference between the Expenditure(as % of GDP) in Lebanon in 2008 and the Expenditure(as % of GDP) in Tajikistan in 2011?
Offer a very short reply. -22. What is the difference between the Expenditure(as % of GDP) of Mexico in 2008 and the Expenditure(as % of GDP) of Tajikistan in 2011?
Ensure brevity in your answer.  -44.55. What is the difference between the Expenditure(as % of GDP) in Azerbaijan in 2009 and the Expenditure(as % of GDP) in Lebanon in 2010?
Offer a very short reply. -15.36. What is the difference between the Expenditure(as % of GDP) in Azerbaijan in 2009 and the Expenditure(as % of GDP) in Mexico in 2010?
Provide a succinct answer. 0.73. What is the difference between the Expenditure(as % of GDP) in Azerbaijan in 2009 and the Expenditure(as % of GDP) in Tajikistan in 2010?
Give a very brief answer. -38.03. What is the difference between the Expenditure(as % of GDP) in Lebanon in 2009 and the Expenditure(as % of GDP) in Mexico in 2010?
Offer a terse response. 19.41. What is the difference between the Expenditure(as % of GDP) of Lebanon in 2009 and the Expenditure(as % of GDP) of Tajikistan in 2010?
Offer a terse response. -19.36. What is the difference between the Expenditure(as % of GDP) of Mexico in 2009 and the Expenditure(as % of GDP) of Tajikistan in 2010?
Offer a terse response. -38.4. What is the difference between the Expenditure(as % of GDP) of Azerbaijan in 2009 and the Expenditure(as % of GDP) of Lebanon in 2011?
Your answer should be very brief. -14.42. What is the difference between the Expenditure(as % of GDP) of Azerbaijan in 2009 and the Expenditure(as % of GDP) of Mexico in 2011?
Your answer should be compact. 0.82. What is the difference between the Expenditure(as % of GDP) in Azerbaijan in 2009 and the Expenditure(as % of GDP) in Tajikistan in 2011?
Provide a succinct answer. -44.08. What is the difference between the Expenditure(as % of GDP) in Lebanon in 2009 and the Expenditure(as % of GDP) in Mexico in 2011?
Ensure brevity in your answer.  19.49. What is the difference between the Expenditure(as % of GDP) of Lebanon in 2009 and the Expenditure(as % of GDP) of Tajikistan in 2011?
Your answer should be very brief. -25.4. What is the difference between the Expenditure(as % of GDP) in Mexico in 2009 and the Expenditure(as % of GDP) in Tajikistan in 2011?
Give a very brief answer. -44.44. What is the difference between the Expenditure(as % of GDP) in Azerbaijan in 2010 and the Expenditure(as % of GDP) in Lebanon in 2011?
Your response must be concise. -14.58. What is the difference between the Expenditure(as % of GDP) in Azerbaijan in 2010 and the Expenditure(as % of GDP) in Mexico in 2011?
Your answer should be very brief. 0.65. What is the difference between the Expenditure(as % of GDP) of Azerbaijan in 2010 and the Expenditure(as % of GDP) of Tajikistan in 2011?
Your answer should be very brief. -44.24. What is the difference between the Expenditure(as % of GDP) in Lebanon in 2010 and the Expenditure(as % of GDP) in Mexico in 2011?
Make the answer very short. 16.17. What is the difference between the Expenditure(as % of GDP) in Lebanon in 2010 and the Expenditure(as % of GDP) in Tajikistan in 2011?
Ensure brevity in your answer.  -28.72. What is the difference between the Expenditure(as % of GDP) of Mexico in 2010 and the Expenditure(as % of GDP) of Tajikistan in 2011?
Keep it short and to the point. -44.81. What is the average Expenditure(as % of GDP) in Azerbaijan per year?
Your response must be concise. 3.3. What is the average Expenditure(as % of GDP) of Lebanon per year?
Provide a succinct answer. 22.38. What is the average Expenditure(as % of GDP) of Mexico per year?
Make the answer very short. 2.44. What is the average Expenditure(as % of GDP) of Tajikistan per year?
Your answer should be very brief. 35.74. In the year 2004, what is the difference between the Expenditure(as % of GDP) in Azerbaijan and Expenditure(as % of GDP) in Lebanon?
Your answer should be compact. -24.06. In the year 2004, what is the difference between the Expenditure(as % of GDP) in Azerbaijan and Expenditure(as % of GDP) in Mexico?
Your answer should be compact. 0.04. In the year 2004, what is the difference between the Expenditure(as % of GDP) of Azerbaijan and Expenditure(as % of GDP) of Tajikistan?
Your answer should be very brief. -9.52. In the year 2004, what is the difference between the Expenditure(as % of GDP) of Lebanon and Expenditure(as % of GDP) of Mexico?
Your response must be concise. 24.1. In the year 2004, what is the difference between the Expenditure(as % of GDP) of Lebanon and Expenditure(as % of GDP) of Tajikistan?
Provide a short and direct response. 14.54. In the year 2004, what is the difference between the Expenditure(as % of GDP) of Mexico and Expenditure(as % of GDP) of Tajikistan?
Keep it short and to the point. -9.56. In the year 2005, what is the difference between the Expenditure(as % of GDP) in Azerbaijan and Expenditure(as % of GDP) in Lebanon?
Provide a short and direct response. -18.43. In the year 2005, what is the difference between the Expenditure(as % of GDP) of Azerbaijan and Expenditure(as % of GDP) of Mexico?
Keep it short and to the point. 2.08. In the year 2005, what is the difference between the Expenditure(as % of GDP) of Azerbaijan and Expenditure(as % of GDP) of Tajikistan?
Provide a short and direct response. -15.48. In the year 2005, what is the difference between the Expenditure(as % of GDP) in Lebanon and Expenditure(as % of GDP) in Mexico?
Offer a terse response. 20.51. In the year 2005, what is the difference between the Expenditure(as % of GDP) of Lebanon and Expenditure(as % of GDP) of Tajikistan?
Ensure brevity in your answer.  2.95. In the year 2005, what is the difference between the Expenditure(as % of GDP) of Mexico and Expenditure(as % of GDP) of Tajikistan?
Offer a terse response. -17.56. In the year 2006, what is the difference between the Expenditure(as % of GDP) of Azerbaijan and Expenditure(as % of GDP) of Lebanon?
Offer a terse response. -20.1. In the year 2006, what is the difference between the Expenditure(as % of GDP) of Azerbaijan and Expenditure(as % of GDP) of Mexico?
Make the answer very short. 1.02. In the year 2006, what is the difference between the Expenditure(as % of GDP) of Azerbaijan and Expenditure(as % of GDP) of Tajikistan?
Offer a terse response. -32.23. In the year 2006, what is the difference between the Expenditure(as % of GDP) in Lebanon and Expenditure(as % of GDP) in Mexico?
Give a very brief answer. 21.12. In the year 2006, what is the difference between the Expenditure(as % of GDP) of Lebanon and Expenditure(as % of GDP) of Tajikistan?
Offer a terse response. -12.13. In the year 2006, what is the difference between the Expenditure(as % of GDP) in Mexico and Expenditure(as % of GDP) in Tajikistan?
Your answer should be compact. -33.25. In the year 2007, what is the difference between the Expenditure(as % of GDP) of Azerbaijan and Expenditure(as % of GDP) of Lebanon?
Your answer should be compact. -19.64. In the year 2007, what is the difference between the Expenditure(as % of GDP) in Azerbaijan and Expenditure(as % of GDP) in Mexico?
Offer a very short reply. 1.26. In the year 2007, what is the difference between the Expenditure(as % of GDP) in Azerbaijan and Expenditure(as % of GDP) in Tajikistan?
Give a very brief answer. -41.62. In the year 2007, what is the difference between the Expenditure(as % of GDP) of Lebanon and Expenditure(as % of GDP) of Mexico?
Provide a short and direct response. 20.9. In the year 2007, what is the difference between the Expenditure(as % of GDP) in Lebanon and Expenditure(as % of GDP) in Tajikistan?
Your answer should be very brief. -21.98. In the year 2007, what is the difference between the Expenditure(as % of GDP) in Mexico and Expenditure(as % of GDP) in Tajikistan?
Ensure brevity in your answer.  -42.88. In the year 2008, what is the difference between the Expenditure(as % of GDP) of Azerbaijan and Expenditure(as % of GDP) of Lebanon?
Give a very brief answer. -21.8. In the year 2008, what is the difference between the Expenditure(as % of GDP) in Azerbaijan and Expenditure(as % of GDP) in Mexico?
Ensure brevity in your answer.  0.74. In the year 2008, what is the difference between the Expenditure(as % of GDP) of Azerbaijan and Expenditure(as % of GDP) of Tajikistan?
Keep it short and to the point. -46.18. In the year 2008, what is the difference between the Expenditure(as % of GDP) of Lebanon and Expenditure(as % of GDP) of Mexico?
Ensure brevity in your answer.  22.54. In the year 2008, what is the difference between the Expenditure(as % of GDP) of Lebanon and Expenditure(as % of GDP) of Tajikistan?
Give a very brief answer. -24.38. In the year 2008, what is the difference between the Expenditure(as % of GDP) in Mexico and Expenditure(as % of GDP) in Tajikistan?
Offer a very short reply. -46.93. In the year 2009, what is the difference between the Expenditure(as % of GDP) in Azerbaijan and Expenditure(as % of GDP) in Lebanon?
Offer a very short reply. -18.68. In the year 2009, what is the difference between the Expenditure(as % of GDP) in Azerbaijan and Expenditure(as % of GDP) in Mexico?
Keep it short and to the point. 0.36. In the year 2009, what is the difference between the Expenditure(as % of GDP) in Azerbaijan and Expenditure(as % of GDP) in Tajikistan?
Keep it short and to the point. -32.27. In the year 2009, what is the difference between the Expenditure(as % of GDP) in Lebanon and Expenditure(as % of GDP) in Mexico?
Your answer should be very brief. 19.04. In the year 2009, what is the difference between the Expenditure(as % of GDP) of Lebanon and Expenditure(as % of GDP) of Tajikistan?
Keep it short and to the point. -13.6. In the year 2009, what is the difference between the Expenditure(as % of GDP) in Mexico and Expenditure(as % of GDP) in Tajikistan?
Ensure brevity in your answer.  -32.64. In the year 2010, what is the difference between the Expenditure(as % of GDP) in Azerbaijan and Expenditure(as % of GDP) in Lebanon?
Offer a terse response. -15.52. In the year 2010, what is the difference between the Expenditure(as % of GDP) in Azerbaijan and Expenditure(as % of GDP) in Mexico?
Provide a short and direct response. 0.56. In the year 2010, what is the difference between the Expenditure(as % of GDP) in Azerbaijan and Expenditure(as % of GDP) in Tajikistan?
Offer a terse response. -38.2. In the year 2010, what is the difference between the Expenditure(as % of GDP) in Lebanon and Expenditure(as % of GDP) in Mexico?
Your answer should be very brief. 16.09. In the year 2010, what is the difference between the Expenditure(as % of GDP) of Lebanon and Expenditure(as % of GDP) of Tajikistan?
Keep it short and to the point. -22.68. In the year 2010, what is the difference between the Expenditure(as % of GDP) of Mexico and Expenditure(as % of GDP) of Tajikistan?
Keep it short and to the point. -38.76. In the year 2011, what is the difference between the Expenditure(as % of GDP) of Azerbaijan and Expenditure(as % of GDP) of Lebanon?
Ensure brevity in your answer.  -14.38. In the year 2011, what is the difference between the Expenditure(as % of GDP) in Azerbaijan and Expenditure(as % of GDP) in Mexico?
Ensure brevity in your answer.  0.85. In the year 2011, what is the difference between the Expenditure(as % of GDP) in Azerbaijan and Expenditure(as % of GDP) in Tajikistan?
Your response must be concise. -44.04. In the year 2011, what is the difference between the Expenditure(as % of GDP) of Lebanon and Expenditure(as % of GDP) of Mexico?
Make the answer very short. 15.23. In the year 2011, what is the difference between the Expenditure(as % of GDP) in Lebanon and Expenditure(as % of GDP) in Tajikistan?
Give a very brief answer. -29.66. In the year 2011, what is the difference between the Expenditure(as % of GDP) of Mexico and Expenditure(as % of GDP) of Tajikistan?
Keep it short and to the point. -44.89. What is the ratio of the Expenditure(as % of GDP) of Azerbaijan in 2004 to that in 2005?
Offer a very short reply. 0.56. What is the ratio of the Expenditure(as % of GDP) of Lebanon in 2004 to that in 2005?
Keep it short and to the point. 1.15. What is the ratio of the Expenditure(as % of GDP) of Mexico in 2004 to that in 2005?
Offer a terse response. 0.98. What is the ratio of the Expenditure(as % of GDP) in Tajikistan in 2004 to that in 2005?
Keep it short and to the point. 0.6. What is the ratio of the Expenditure(as % of GDP) in Azerbaijan in 2004 to that in 2006?
Keep it short and to the point. 0.7. What is the ratio of the Expenditure(as % of GDP) in Lebanon in 2004 to that in 2006?
Give a very brief answer. 1.12. What is the ratio of the Expenditure(as % of GDP) of Mexico in 2004 to that in 2006?
Give a very brief answer. 0.94. What is the ratio of the Expenditure(as % of GDP) in Tajikistan in 2004 to that in 2006?
Your answer should be compact. 0.34. What is the ratio of the Expenditure(as % of GDP) of Azerbaijan in 2004 to that in 2007?
Offer a very short reply. 0.68. What is the ratio of the Expenditure(as % of GDP) in Lebanon in 2004 to that in 2007?
Provide a succinct answer. 1.14. What is the ratio of the Expenditure(as % of GDP) in Tajikistan in 2004 to that in 2007?
Your answer should be very brief. 0.27. What is the ratio of the Expenditure(as % of GDP) in Azerbaijan in 2004 to that in 2008?
Provide a succinct answer. 0.84. What is the ratio of the Expenditure(as % of GDP) in Lebanon in 2004 to that in 2008?
Make the answer very short. 1.07. What is the ratio of the Expenditure(as % of GDP) of Mexico in 2004 to that in 2008?
Make the answer very short. 1.09. What is the ratio of the Expenditure(as % of GDP) in Tajikistan in 2004 to that in 2008?
Keep it short and to the point. 0.25. What is the ratio of the Expenditure(as % of GDP) of Azerbaijan in 2004 to that in 2009?
Offer a very short reply. 0.93. What is the ratio of the Expenditure(as % of GDP) in Lebanon in 2004 to that in 2009?
Provide a short and direct response. 1.24. What is the ratio of the Expenditure(as % of GDP) in Mexico in 2004 to that in 2009?
Provide a short and direct response. 1.04. What is the ratio of the Expenditure(as % of GDP) of Tajikistan in 2004 to that in 2009?
Provide a short and direct response. 0.35. What is the ratio of the Expenditure(as % of GDP) in Azerbaijan in 2004 to that in 2010?
Your response must be concise. 0.98. What is the ratio of the Expenditure(as % of GDP) of Lebanon in 2004 to that in 2010?
Provide a short and direct response. 1.47. What is the ratio of the Expenditure(as % of GDP) of Mexico in 2004 to that in 2010?
Offer a very short reply. 1.23. What is the ratio of the Expenditure(as % of GDP) in Tajikistan in 2004 to that in 2010?
Provide a succinct answer. 0.3. What is the ratio of the Expenditure(as % of GDP) in Azerbaijan in 2004 to that in 2011?
Your response must be concise. 0.91. What is the ratio of the Expenditure(as % of GDP) in Lebanon in 2004 to that in 2011?
Your answer should be compact. 1.55. What is the ratio of the Expenditure(as % of GDP) of Mexico in 2004 to that in 2011?
Offer a very short reply. 1.28. What is the ratio of the Expenditure(as % of GDP) in Tajikistan in 2004 to that in 2011?
Offer a very short reply. 0.26. What is the ratio of the Expenditure(as % of GDP) of Azerbaijan in 2005 to that in 2006?
Provide a short and direct response. 1.25. What is the ratio of the Expenditure(as % of GDP) of Lebanon in 2005 to that in 2006?
Your answer should be very brief. 0.97. What is the ratio of the Expenditure(as % of GDP) of Mexico in 2005 to that in 2006?
Keep it short and to the point. 0.95. What is the ratio of the Expenditure(as % of GDP) in Tajikistan in 2005 to that in 2006?
Provide a short and direct response. 0.56. What is the ratio of the Expenditure(as % of GDP) in Azerbaijan in 2005 to that in 2007?
Make the answer very short. 1.23. What is the ratio of the Expenditure(as % of GDP) in Lebanon in 2005 to that in 2007?
Offer a very short reply. 0.99. What is the ratio of the Expenditure(as % of GDP) of Mexico in 2005 to that in 2007?
Your response must be concise. 1.02. What is the ratio of the Expenditure(as % of GDP) of Tajikistan in 2005 to that in 2007?
Your answer should be compact. 0.44. What is the ratio of the Expenditure(as % of GDP) of Azerbaijan in 2005 to that in 2008?
Give a very brief answer. 1.51. What is the ratio of the Expenditure(as % of GDP) in Lebanon in 2005 to that in 2008?
Your answer should be compact. 0.93. What is the ratio of the Expenditure(as % of GDP) in Mexico in 2005 to that in 2008?
Make the answer very short. 1.11. What is the ratio of the Expenditure(as % of GDP) of Tajikistan in 2005 to that in 2008?
Offer a terse response. 0.41. What is the ratio of the Expenditure(as % of GDP) in Azerbaijan in 2005 to that in 2009?
Provide a short and direct response. 1.66. What is the ratio of the Expenditure(as % of GDP) in Lebanon in 2005 to that in 2009?
Make the answer very short. 1.08. What is the ratio of the Expenditure(as % of GDP) of Mexico in 2005 to that in 2009?
Keep it short and to the point. 1.06. What is the ratio of the Expenditure(as % of GDP) in Tajikistan in 2005 to that in 2009?
Your answer should be compact. 0.57. What is the ratio of the Expenditure(as % of GDP) in Azerbaijan in 2005 to that in 2010?
Provide a succinct answer. 1.76. What is the ratio of the Expenditure(as % of GDP) in Lebanon in 2005 to that in 2010?
Keep it short and to the point. 1.27. What is the ratio of the Expenditure(as % of GDP) of Mexico in 2005 to that in 2010?
Provide a succinct answer. 1.25. What is the ratio of the Expenditure(as % of GDP) in Tajikistan in 2005 to that in 2010?
Give a very brief answer. 0.49. What is the ratio of the Expenditure(as % of GDP) of Azerbaijan in 2005 to that in 2011?
Provide a succinct answer. 1.64. What is the ratio of the Expenditure(as % of GDP) in Lebanon in 2005 to that in 2011?
Your answer should be very brief. 1.34. What is the ratio of the Expenditure(as % of GDP) in Mexico in 2005 to that in 2011?
Provide a succinct answer. 1.3. What is the ratio of the Expenditure(as % of GDP) in Tajikistan in 2005 to that in 2011?
Provide a succinct answer. 0.43. What is the ratio of the Expenditure(as % of GDP) of Azerbaijan in 2006 to that in 2007?
Offer a terse response. 0.98. What is the ratio of the Expenditure(as % of GDP) of Lebanon in 2006 to that in 2007?
Make the answer very short. 1.02. What is the ratio of the Expenditure(as % of GDP) in Mexico in 2006 to that in 2007?
Your answer should be very brief. 1.07. What is the ratio of the Expenditure(as % of GDP) in Tajikistan in 2006 to that in 2007?
Provide a succinct answer. 0.79. What is the ratio of the Expenditure(as % of GDP) of Azerbaijan in 2006 to that in 2008?
Provide a succinct answer. 1.21. What is the ratio of the Expenditure(as % of GDP) of Mexico in 2006 to that in 2008?
Ensure brevity in your answer.  1.16. What is the ratio of the Expenditure(as % of GDP) in Tajikistan in 2006 to that in 2008?
Your answer should be very brief. 0.73. What is the ratio of the Expenditure(as % of GDP) of Azerbaijan in 2006 to that in 2009?
Ensure brevity in your answer.  1.33. What is the ratio of the Expenditure(as % of GDP) in Lebanon in 2006 to that in 2009?
Offer a terse response. 1.11. What is the ratio of the Expenditure(as % of GDP) of Mexico in 2006 to that in 2009?
Provide a short and direct response. 1.11. What is the ratio of the Expenditure(as % of GDP) of Tajikistan in 2006 to that in 2009?
Your answer should be compact. 1.03. What is the ratio of the Expenditure(as % of GDP) of Azerbaijan in 2006 to that in 2010?
Offer a terse response. 1.41. What is the ratio of the Expenditure(as % of GDP) in Lebanon in 2006 to that in 2010?
Ensure brevity in your answer.  1.31. What is the ratio of the Expenditure(as % of GDP) in Mexico in 2006 to that in 2010?
Make the answer very short. 1.31. What is the ratio of the Expenditure(as % of GDP) of Tajikistan in 2006 to that in 2010?
Offer a very short reply. 0.88. What is the ratio of the Expenditure(as % of GDP) of Azerbaijan in 2006 to that in 2011?
Your response must be concise. 1.31. What is the ratio of the Expenditure(as % of GDP) of Lebanon in 2006 to that in 2011?
Keep it short and to the point. 1.38. What is the ratio of the Expenditure(as % of GDP) in Mexico in 2006 to that in 2011?
Offer a terse response. 1.36. What is the ratio of the Expenditure(as % of GDP) of Tajikistan in 2006 to that in 2011?
Give a very brief answer. 0.77. What is the ratio of the Expenditure(as % of GDP) of Azerbaijan in 2007 to that in 2008?
Your answer should be very brief. 1.23. What is the ratio of the Expenditure(as % of GDP) in Lebanon in 2007 to that in 2008?
Provide a short and direct response. 0.94. What is the ratio of the Expenditure(as % of GDP) in Mexico in 2007 to that in 2008?
Give a very brief answer. 1.09. What is the ratio of the Expenditure(as % of GDP) in Tajikistan in 2007 to that in 2008?
Ensure brevity in your answer.  0.92. What is the ratio of the Expenditure(as % of GDP) of Azerbaijan in 2007 to that in 2009?
Keep it short and to the point. 1.35. What is the ratio of the Expenditure(as % of GDP) in Lebanon in 2007 to that in 2009?
Provide a succinct answer. 1.09. What is the ratio of the Expenditure(as % of GDP) of Mexico in 2007 to that in 2009?
Offer a terse response. 1.04. What is the ratio of the Expenditure(as % of GDP) in Tajikistan in 2007 to that in 2009?
Make the answer very short. 1.29. What is the ratio of the Expenditure(as % of GDP) in Azerbaijan in 2007 to that in 2010?
Make the answer very short. 1.44. What is the ratio of the Expenditure(as % of GDP) in Lebanon in 2007 to that in 2010?
Your response must be concise. 1.29. What is the ratio of the Expenditure(as % of GDP) of Mexico in 2007 to that in 2010?
Give a very brief answer. 1.23. What is the ratio of the Expenditure(as % of GDP) in Tajikistan in 2007 to that in 2010?
Your answer should be very brief. 1.11. What is the ratio of the Expenditure(as % of GDP) of Azerbaijan in 2007 to that in 2011?
Make the answer very short. 1.34. What is the ratio of the Expenditure(as % of GDP) in Lebanon in 2007 to that in 2011?
Your response must be concise. 1.36. What is the ratio of the Expenditure(as % of GDP) of Mexico in 2007 to that in 2011?
Provide a succinct answer. 1.28. What is the ratio of the Expenditure(as % of GDP) of Azerbaijan in 2008 to that in 2009?
Your answer should be very brief. 1.1. What is the ratio of the Expenditure(as % of GDP) of Lebanon in 2008 to that in 2009?
Make the answer very short. 1.16. What is the ratio of the Expenditure(as % of GDP) in Mexico in 2008 to that in 2009?
Offer a very short reply. 0.96. What is the ratio of the Expenditure(as % of GDP) in Tajikistan in 2008 to that in 2009?
Provide a short and direct response. 1.4. What is the ratio of the Expenditure(as % of GDP) in Azerbaijan in 2008 to that in 2010?
Offer a terse response. 1.17. What is the ratio of the Expenditure(as % of GDP) in Lebanon in 2008 to that in 2010?
Your answer should be compact. 1.37. What is the ratio of the Expenditure(as % of GDP) of Mexico in 2008 to that in 2010?
Your answer should be compact. 1.12. What is the ratio of the Expenditure(as % of GDP) in Tajikistan in 2008 to that in 2010?
Keep it short and to the point. 1.21. What is the ratio of the Expenditure(as % of GDP) in Azerbaijan in 2008 to that in 2011?
Your response must be concise. 1.08. What is the ratio of the Expenditure(as % of GDP) in Lebanon in 2008 to that in 2011?
Give a very brief answer. 1.44. What is the ratio of the Expenditure(as % of GDP) of Mexico in 2008 to that in 2011?
Keep it short and to the point. 1.17. What is the ratio of the Expenditure(as % of GDP) of Tajikistan in 2008 to that in 2011?
Keep it short and to the point. 1.05. What is the ratio of the Expenditure(as % of GDP) of Azerbaijan in 2009 to that in 2010?
Your response must be concise. 1.06. What is the ratio of the Expenditure(as % of GDP) of Lebanon in 2009 to that in 2010?
Make the answer very short. 1.18. What is the ratio of the Expenditure(as % of GDP) of Mexico in 2009 to that in 2010?
Give a very brief answer. 1.18. What is the ratio of the Expenditure(as % of GDP) of Tajikistan in 2009 to that in 2010?
Offer a terse response. 0.86. What is the ratio of the Expenditure(as % of GDP) in Azerbaijan in 2009 to that in 2011?
Offer a very short reply. 0.99. What is the ratio of the Expenditure(as % of GDP) of Lebanon in 2009 to that in 2011?
Provide a succinct answer. 1.25. What is the ratio of the Expenditure(as % of GDP) of Mexico in 2009 to that in 2011?
Offer a terse response. 1.23. What is the ratio of the Expenditure(as % of GDP) in Tajikistan in 2009 to that in 2011?
Ensure brevity in your answer.  0.75. What is the ratio of the Expenditure(as % of GDP) of Azerbaijan in 2010 to that in 2011?
Provide a short and direct response. 0.93. What is the ratio of the Expenditure(as % of GDP) of Lebanon in 2010 to that in 2011?
Your response must be concise. 1.05. What is the ratio of the Expenditure(as % of GDP) in Mexico in 2010 to that in 2011?
Ensure brevity in your answer.  1.04. What is the ratio of the Expenditure(as % of GDP) of Tajikistan in 2010 to that in 2011?
Your answer should be compact. 0.87. What is the difference between the highest and the second highest Expenditure(as % of GDP) of Azerbaijan?
Make the answer very short. 0.87. What is the difference between the highest and the second highest Expenditure(as % of GDP) in Lebanon?
Your answer should be very brief. 1.78. What is the difference between the highest and the second highest Expenditure(as % of GDP) in Mexico?
Your response must be concise. 0.12. What is the difference between the highest and the second highest Expenditure(as % of GDP) of Tajikistan?
Ensure brevity in your answer.  2.38. What is the difference between the highest and the lowest Expenditure(as % of GDP) of Azerbaijan?
Provide a succinct answer. 2.08. What is the difference between the highest and the lowest Expenditure(as % of GDP) of Lebanon?
Offer a very short reply. 9.43. What is the difference between the highest and the lowest Expenditure(as % of GDP) in Mexico?
Ensure brevity in your answer.  0.73. What is the difference between the highest and the lowest Expenditure(as % of GDP) in Tajikistan?
Keep it short and to the point. 37.15. 